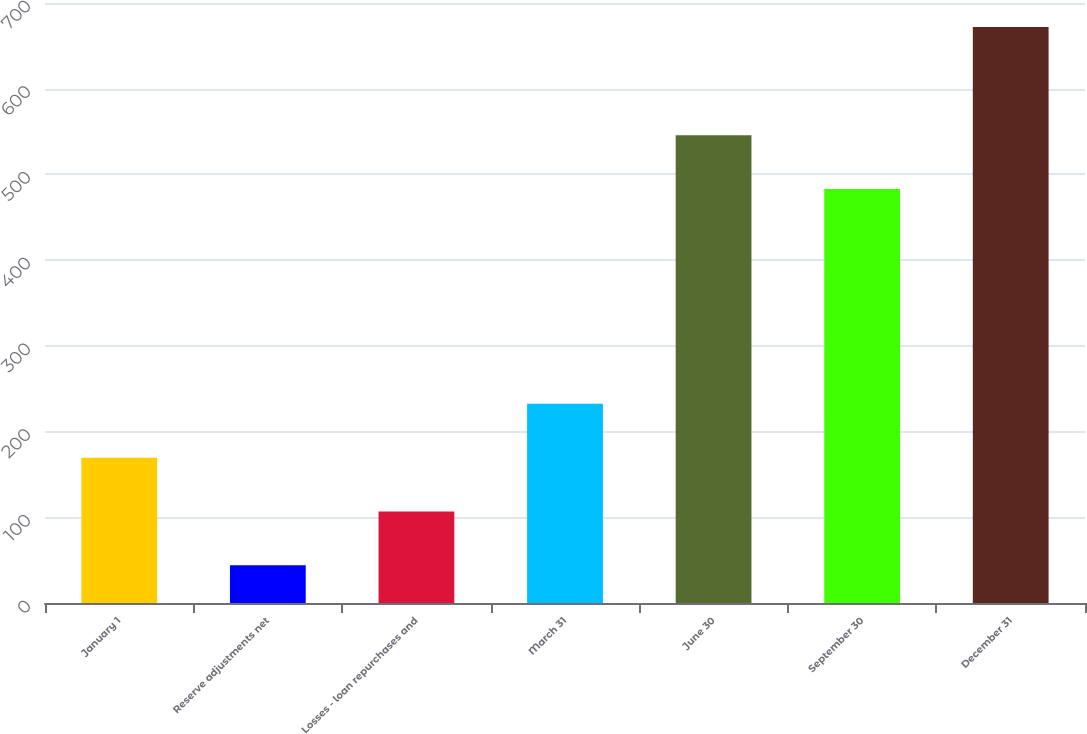<chart> <loc_0><loc_0><loc_500><loc_500><bar_chart><fcel>January 1<fcel>Reserve adjustments net<fcel>Losses - loan repurchases and<fcel>March 31<fcel>June 30<fcel>September 30<fcel>December 31<nl><fcel>169.6<fcel>44<fcel>106.8<fcel>232.4<fcel>545.8<fcel>483<fcel>672<nl></chart> 